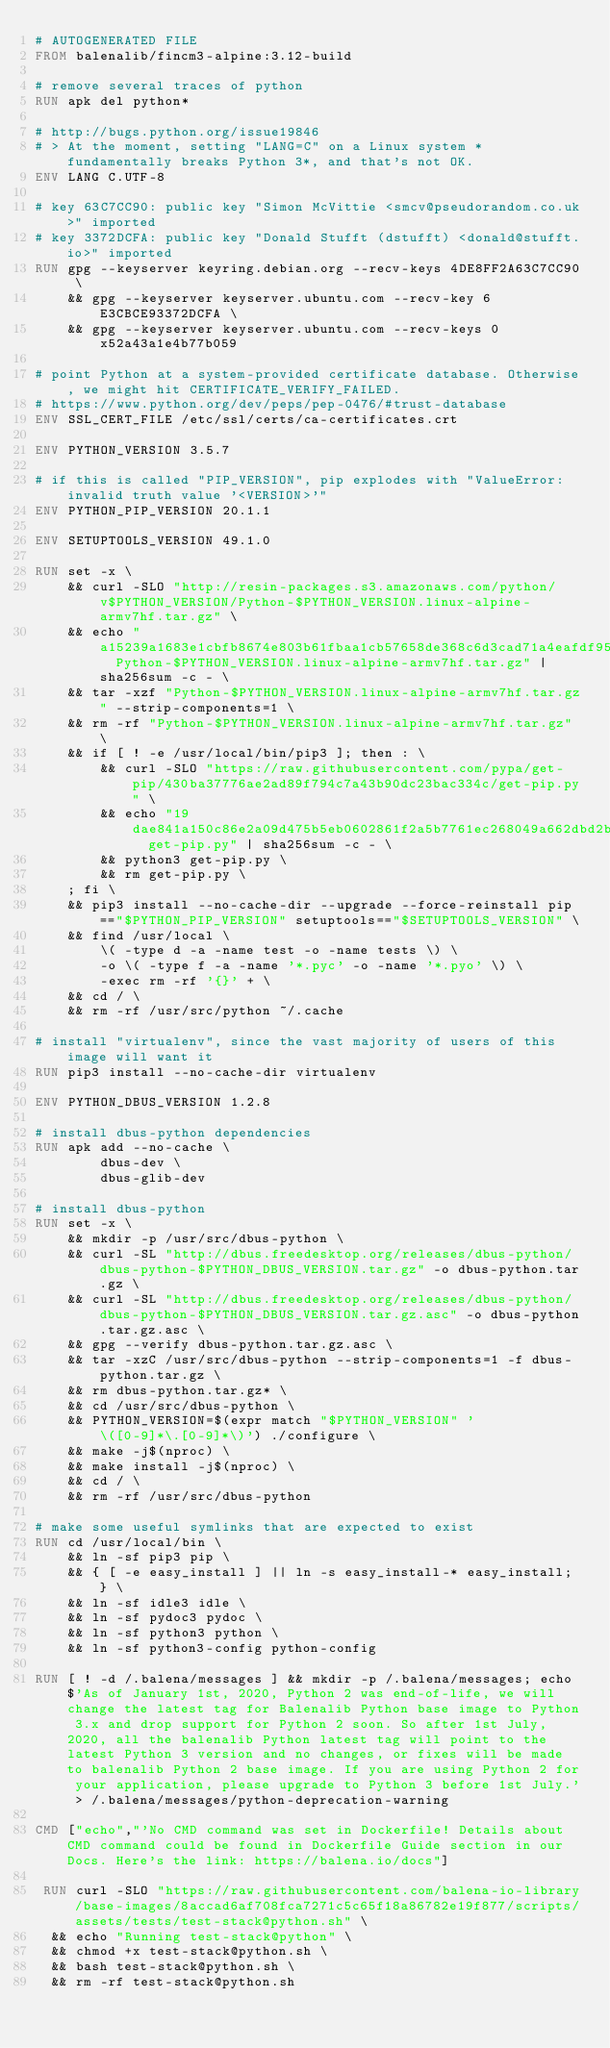Convert code to text. <code><loc_0><loc_0><loc_500><loc_500><_Dockerfile_># AUTOGENERATED FILE
FROM balenalib/fincm3-alpine:3.12-build

# remove several traces of python
RUN apk del python*

# http://bugs.python.org/issue19846
# > At the moment, setting "LANG=C" on a Linux system *fundamentally breaks Python 3*, and that's not OK.
ENV LANG C.UTF-8

# key 63C7CC90: public key "Simon McVittie <smcv@pseudorandom.co.uk>" imported
# key 3372DCFA: public key "Donald Stufft (dstufft) <donald@stufft.io>" imported
RUN gpg --keyserver keyring.debian.org --recv-keys 4DE8FF2A63C7CC90 \
	&& gpg --keyserver keyserver.ubuntu.com --recv-key 6E3CBCE93372DCFA \
	&& gpg --keyserver keyserver.ubuntu.com --recv-keys 0x52a43a1e4b77b059

# point Python at a system-provided certificate database. Otherwise, we might hit CERTIFICATE_VERIFY_FAILED.
# https://www.python.org/dev/peps/pep-0476/#trust-database
ENV SSL_CERT_FILE /etc/ssl/certs/ca-certificates.crt

ENV PYTHON_VERSION 3.5.7

# if this is called "PIP_VERSION", pip explodes with "ValueError: invalid truth value '<VERSION>'"
ENV PYTHON_PIP_VERSION 20.1.1

ENV SETUPTOOLS_VERSION 49.1.0

RUN set -x \
	&& curl -SLO "http://resin-packages.s3.amazonaws.com/python/v$PYTHON_VERSION/Python-$PYTHON_VERSION.linux-alpine-armv7hf.tar.gz" \
	&& echo "a15239a1683e1cbfb8674e803b61fbaa1cb57658de368c6d3cad71a4eafdf954  Python-$PYTHON_VERSION.linux-alpine-armv7hf.tar.gz" | sha256sum -c - \
	&& tar -xzf "Python-$PYTHON_VERSION.linux-alpine-armv7hf.tar.gz" --strip-components=1 \
	&& rm -rf "Python-$PYTHON_VERSION.linux-alpine-armv7hf.tar.gz" \
	&& if [ ! -e /usr/local/bin/pip3 ]; then : \
		&& curl -SLO "https://raw.githubusercontent.com/pypa/get-pip/430ba37776ae2ad89f794c7a43b90dc23bac334c/get-pip.py" \
		&& echo "19dae841a150c86e2a09d475b5eb0602861f2a5b7761ec268049a662dbd2bd0c  get-pip.py" | sha256sum -c - \
		&& python3 get-pip.py \
		&& rm get-pip.py \
	; fi \
	&& pip3 install --no-cache-dir --upgrade --force-reinstall pip=="$PYTHON_PIP_VERSION" setuptools=="$SETUPTOOLS_VERSION" \
	&& find /usr/local \
		\( -type d -a -name test -o -name tests \) \
		-o \( -type f -a -name '*.pyc' -o -name '*.pyo' \) \
		-exec rm -rf '{}' + \
	&& cd / \
	&& rm -rf /usr/src/python ~/.cache

# install "virtualenv", since the vast majority of users of this image will want it
RUN pip3 install --no-cache-dir virtualenv

ENV PYTHON_DBUS_VERSION 1.2.8

# install dbus-python dependencies 
RUN apk add --no-cache \
		dbus-dev \
		dbus-glib-dev

# install dbus-python
RUN set -x \
	&& mkdir -p /usr/src/dbus-python \
	&& curl -SL "http://dbus.freedesktop.org/releases/dbus-python/dbus-python-$PYTHON_DBUS_VERSION.tar.gz" -o dbus-python.tar.gz \
	&& curl -SL "http://dbus.freedesktop.org/releases/dbus-python/dbus-python-$PYTHON_DBUS_VERSION.tar.gz.asc" -o dbus-python.tar.gz.asc \
	&& gpg --verify dbus-python.tar.gz.asc \
	&& tar -xzC /usr/src/dbus-python --strip-components=1 -f dbus-python.tar.gz \
	&& rm dbus-python.tar.gz* \
	&& cd /usr/src/dbus-python \
	&& PYTHON_VERSION=$(expr match "$PYTHON_VERSION" '\([0-9]*\.[0-9]*\)') ./configure \
	&& make -j$(nproc) \
	&& make install -j$(nproc) \
	&& cd / \
	&& rm -rf /usr/src/dbus-python

# make some useful symlinks that are expected to exist
RUN cd /usr/local/bin \
	&& ln -sf pip3 pip \
	&& { [ -e easy_install ] || ln -s easy_install-* easy_install; } \
	&& ln -sf idle3 idle \
	&& ln -sf pydoc3 pydoc \
	&& ln -sf python3 python \
	&& ln -sf python3-config python-config

RUN [ ! -d /.balena/messages ] && mkdir -p /.balena/messages; echo $'As of January 1st, 2020, Python 2 was end-of-life, we will change the latest tag for Balenalib Python base image to Python 3.x and drop support for Python 2 soon. So after 1st July, 2020, all the balenalib Python latest tag will point to the latest Python 3 version and no changes, or fixes will be made to balenalib Python 2 base image. If you are using Python 2 for your application, please upgrade to Python 3 before 1st July.' > /.balena/messages/python-deprecation-warning

CMD ["echo","'No CMD command was set in Dockerfile! Details about CMD command could be found in Dockerfile Guide section in our Docs. Here's the link: https://balena.io/docs"]

 RUN curl -SLO "https://raw.githubusercontent.com/balena-io-library/base-images/8accad6af708fca7271c5c65f18a86782e19f877/scripts/assets/tests/test-stack@python.sh" \
  && echo "Running test-stack@python" \
  && chmod +x test-stack@python.sh \
  && bash test-stack@python.sh \
  && rm -rf test-stack@python.sh 
</code> 